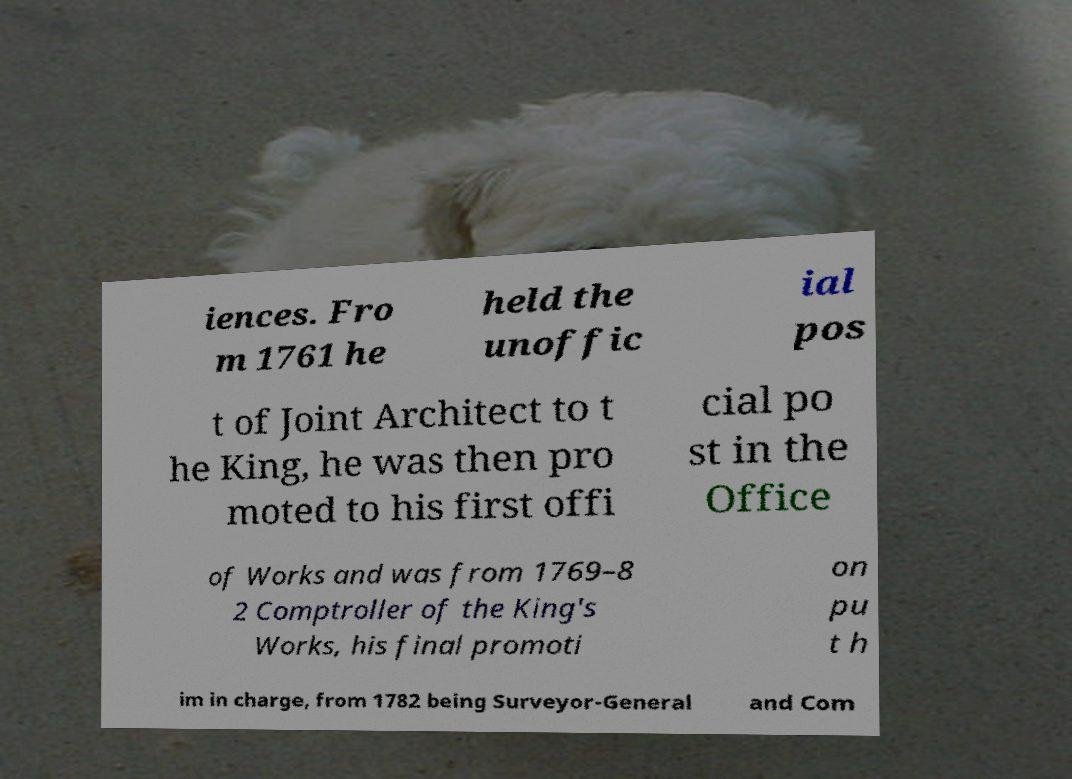Please read and relay the text visible in this image. What does it say? iences. Fro m 1761 he held the unoffic ial pos t of Joint Architect to t he King, he was then pro moted to his first offi cial po st in the Office of Works and was from 1769–8 2 Comptroller of the King's Works, his final promoti on pu t h im in charge, from 1782 being Surveyor-General and Com 